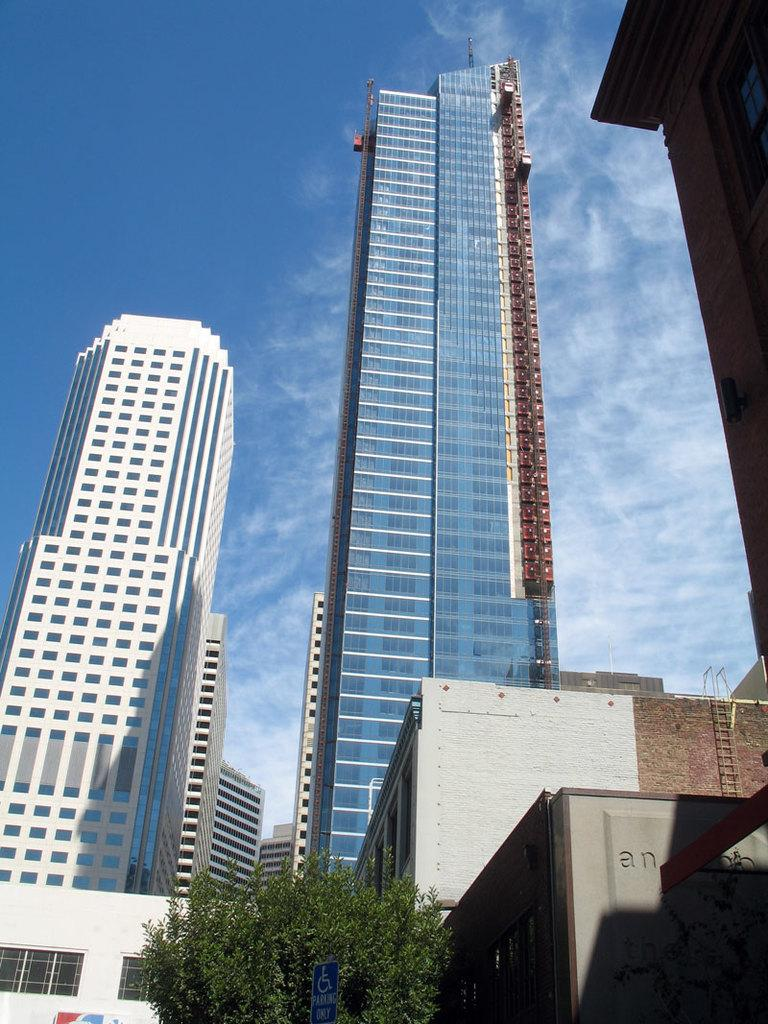What is located at the bottom of the picture? There is a tree at the bottom of the picture. What types of structures can be seen in the image? There are buildings in the image, with colors including white, blue, and grey. What can be seen in the background of the image? The sky is visible in the background of the image, and it is blue in color. Are there any masks hanging from the tree in the image? There are no masks present in the image; it only features a tree, buildings, and a blue sky. 